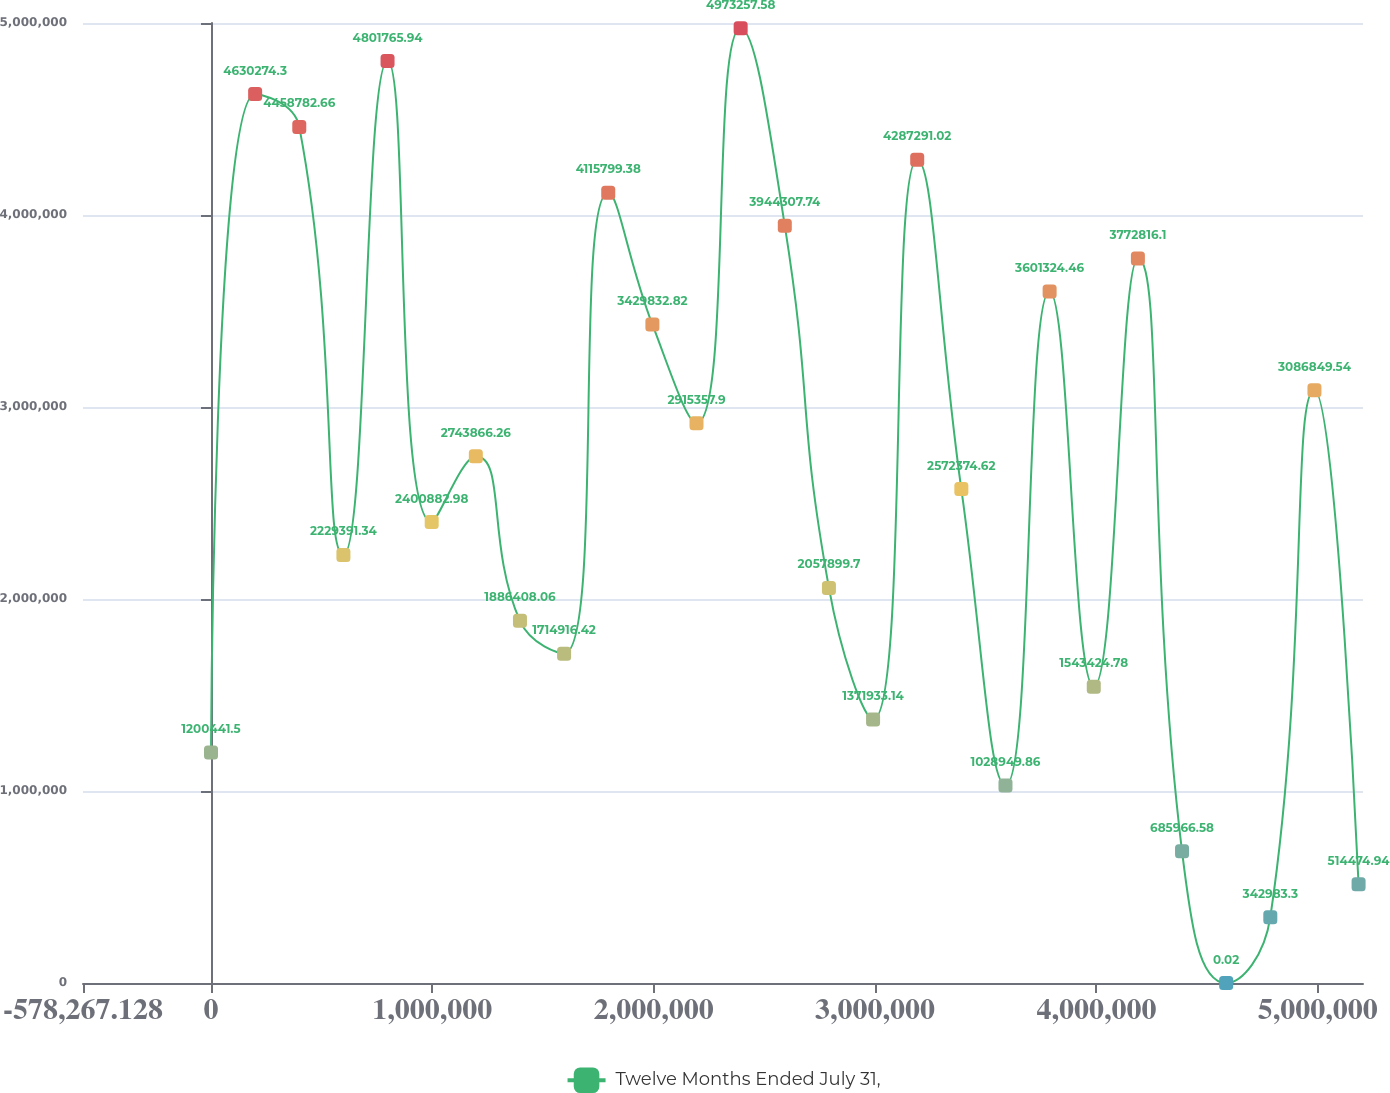Convert chart to OTSL. <chart><loc_0><loc_0><loc_500><loc_500><line_chart><ecel><fcel>Twelve Months Ended July 31,<nl><fcel>10.33<fcel>1.20044e+06<nl><fcel>199416<fcel>4.63027e+06<nl><fcel>398822<fcel>4.45878e+06<nl><fcel>598228<fcel>2.22939e+06<nl><fcel>797634<fcel>4.80177e+06<nl><fcel>997040<fcel>2.40088e+06<nl><fcel>1.19645e+06<fcel>2.74387e+06<nl><fcel>1.39585e+06<fcel>1.88641e+06<nl><fcel>1.59526e+06<fcel>1.71492e+06<nl><fcel>1.79466e+06<fcel>4.1158e+06<nl><fcel>1.99407e+06<fcel>3.42983e+06<nl><fcel>2.19348e+06<fcel>2.91536e+06<nl><fcel>2.39288e+06<fcel>4.97326e+06<nl><fcel>2.59229e+06<fcel>3.94431e+06<nl><fcel>2.79169e+06<fcel>2.0579e+06<nl><fcel>2.9911e+06<fcel>1.37193e+06<nl><fcel>3.19051e+06<fcel>4.28729e+06<nl><fcel>3.38991e+06<fcel>2.57237e+06<nl><fcel>3.58932e+06<fcel>1.02895e+06<nl><fcel>3.78872e+06<fcel>3.60132e+06<nl><fcel>3.98813e+06<fcel>1.54342e+06<nl><fcel>4.18754e+06<fcel>3.77282e+06<nl><fcel>4.38694e+06<fcel>685967<nl><fcel>4.58635e+06<fcel>0.02<nl><fcel>4.78575e+06<fcel>342983<nl><fcel>4.98516e+06<fcel>3.08685e+06<nl><fcel>5.18457e+06<fcel>514475<nl><fcel>5.38397e+06<fcel>171492<nl><fcel>5.58338e+06<fcel>857458<nl><fcel>5.78278e+06<fcel>3.25834e+06<nl></chart> 